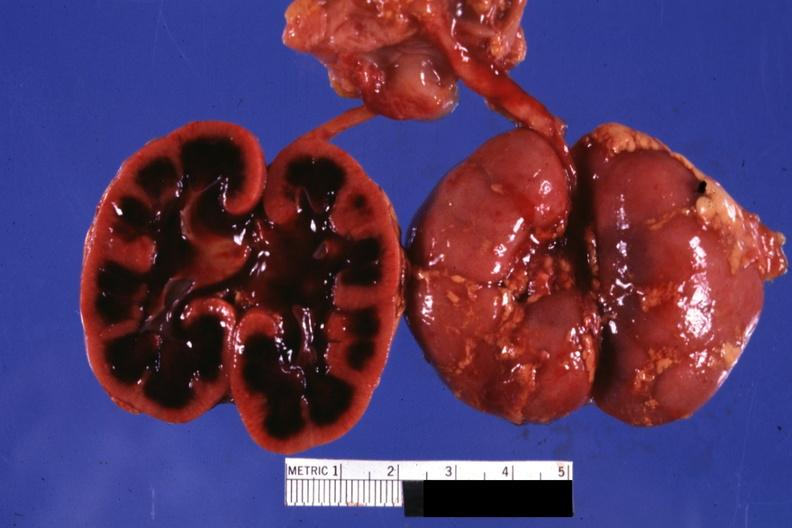does this image show typical cut surface appearance for severe ischemia?
Answer the question using a single word or phrase. Yes 